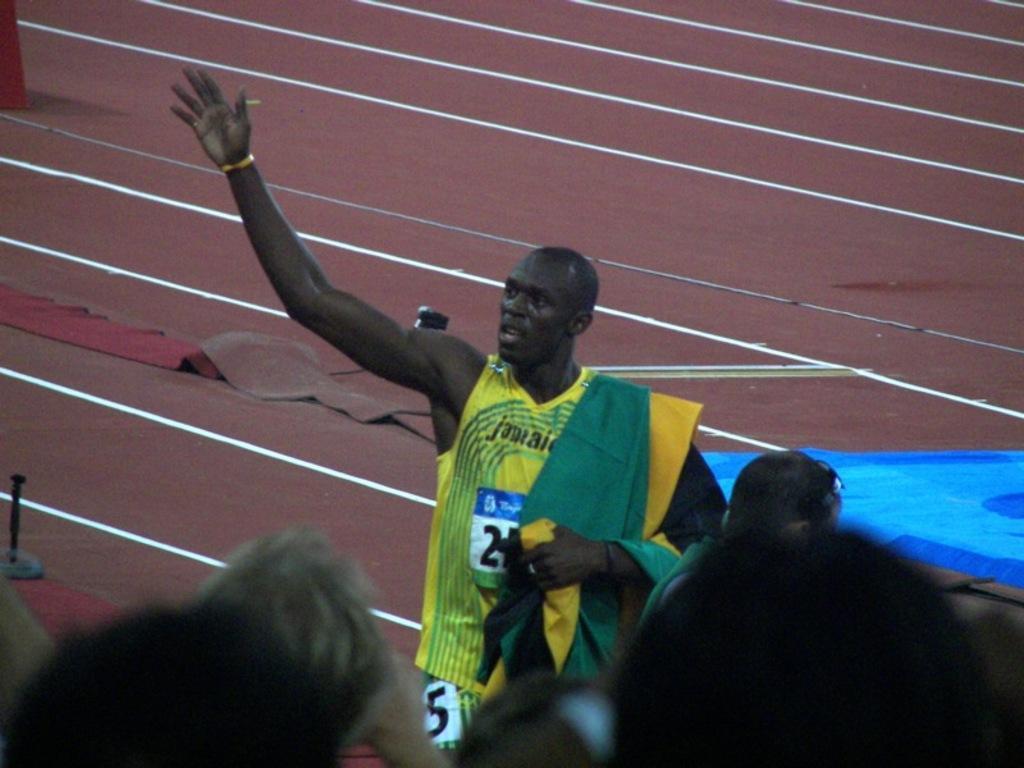In one or two sentences, can you explain what this image depicts? At the bottom of the image there are few people. Behind them there is a man in yellow dress is stunning. In the background there is a brown color floor with white lines. 